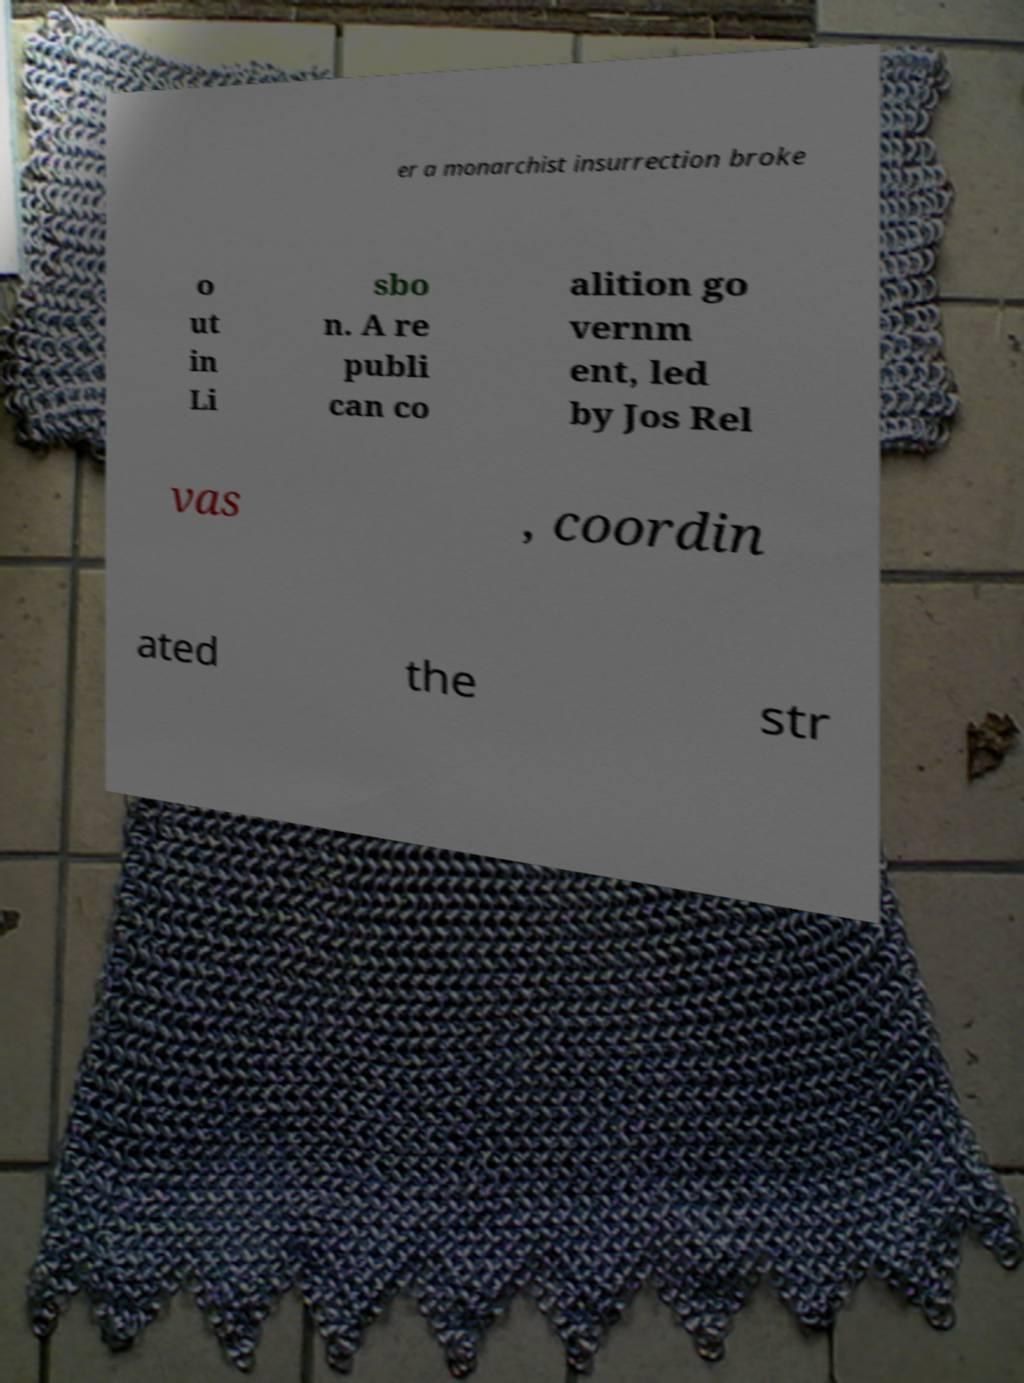For documentation purposes, I need the text within this image transcribed. Could you provide that? er a monarchist insurrection broke o ut in Li sbo n. A re publi can co alition go vernm ent, led by Jos Rel vas , coordin ated the str 